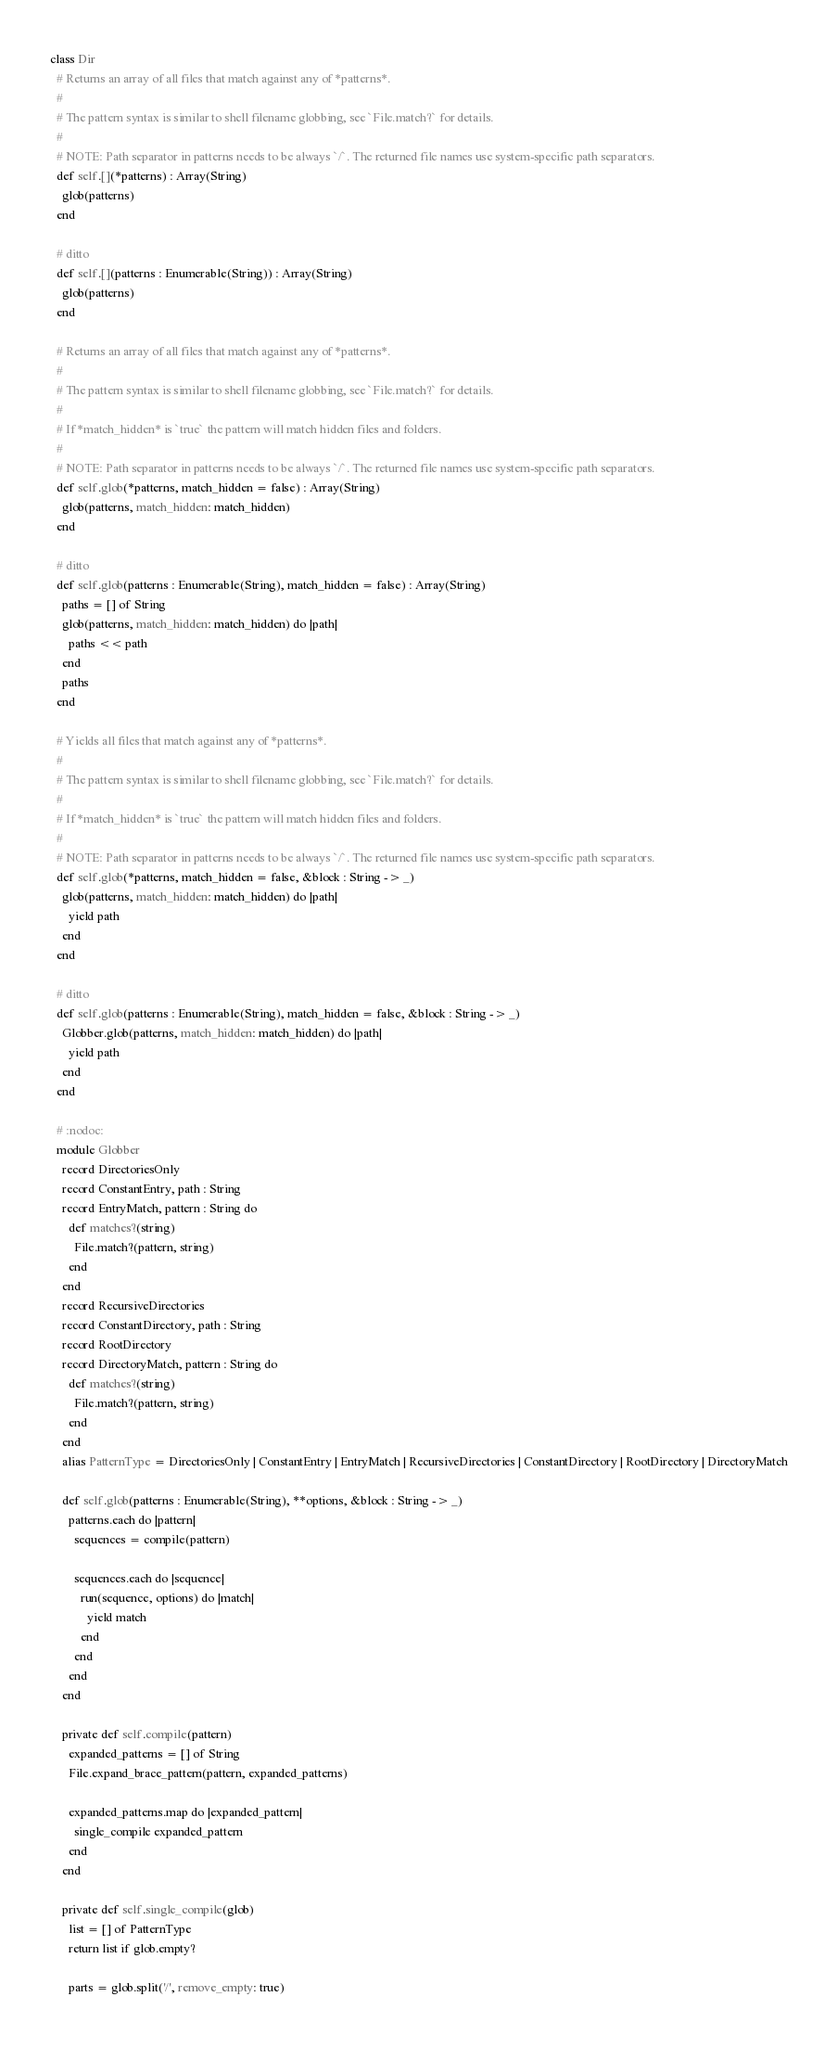Convert code to text. <code><loc_0><loc_0><loc_500><loc_500><_Crystal_>class Dir
  # Returns an array of all files that match against any of *patterns*.
  #
  # The pattern syntax is similar to shell filename globbing, see `File.match?` for details.
  #
  # NOTE: Path separator in patterns needs to be always `/`. The returned file names use system-specific path separators.
  def self.[](*patterns) : Array(String)
    glob(patterns)
  end

  # ditto
  def self.[](patterns : Enumerable(String)) : Array(String)
    glob(patterns)
  end

  # Returns an array of all files that match against any of *patterns*.
  #
  # The pattern syntax is similar to shell filename globbing, see `File.match?` for details.
  #
  # If *match_hidden* is `true` the pattern will match hidden files and folders.
  #
  # NOTE: Path separator in patterns needs to be always `/`. The returned file names use system-specific path separators.
  def self.glob(*patterns, match_hidden = false) : Array(String)
    glob(patterns, match_hidden: match_hidden)
  end

  # ditto
  def self.glob(patterns : Enumerable(String), match_hidden = false) : Array(String)
    paths = [] of String
    glob(patterns, match_hidden: match_hidden) do |path|
      paths << path
    end
    paths
  end

  # Yields all files that match against any of *patterns*.
  #
  # The pattern syntax is similar to shell filename globbing, see `File.match?` for details.
  #
  # If *match_hidden* is `true` the pattern will match hidden files and folders.
  #
  # NOTE: Path separator in patterns needs to be always `/`. The returned file names use system-specific path separators.
  def self.glob(*patterns, match_hidden = false, &block : String -> _)
    glob(patterns, match_hidden: match_hidden) do |path|
      yield path
    end
  end

  # ditto
  def self.glob(patterns : Enumerable(String), match_hidden = false, &block : String -> _)
    Globber.glob(patterns, match_hidden: match_hidden) do |path|
      yield path
    end
  end

  # :nodoc:
  module Globber
    record DirectoriesOnly
    record ConstantEntry, path : String
    record EntryMatch, pattern : String do
      def matches?(string)
        File.match?(pattern, string)
      end
    end
    record RecursiveDirectories
    record ConstantDirectory, path : String
    record RootDirectory
    record DirectoryMatch, pattern : String do
      def matches?(string)
        File.match?(pattern, string)
      end
    end
    alias PatternType = DirectoriesOnly | ConstantEntry | EntryMatch | RecursiveDirectories | ConstantDirectory | RootDirectory | DirectoryMatch

    def self.glob(patterns : Enumerable(String), **options, &block : String -> _)
      patterns.each do |pattern|
        sequences = compile(pattern)

        sequences.each do |sequence|
          run(sequence, options) do |match|
            yield match
          end
        end
      end
    end

    private def self.compile(pattern)
      expanded_patterns = [] of String
      File.expand_brace_pattern(pattern, expanded_patterns)

      expanded_patterns.map do |expanded_pattern|
        single_compile expanded_pattern
      end
    end

    private def self.single_compile(glob)
      list = [] of PatternType
      return list if glob.empty?

      parts = glob.split('/', remove_empty: true)
</code> 